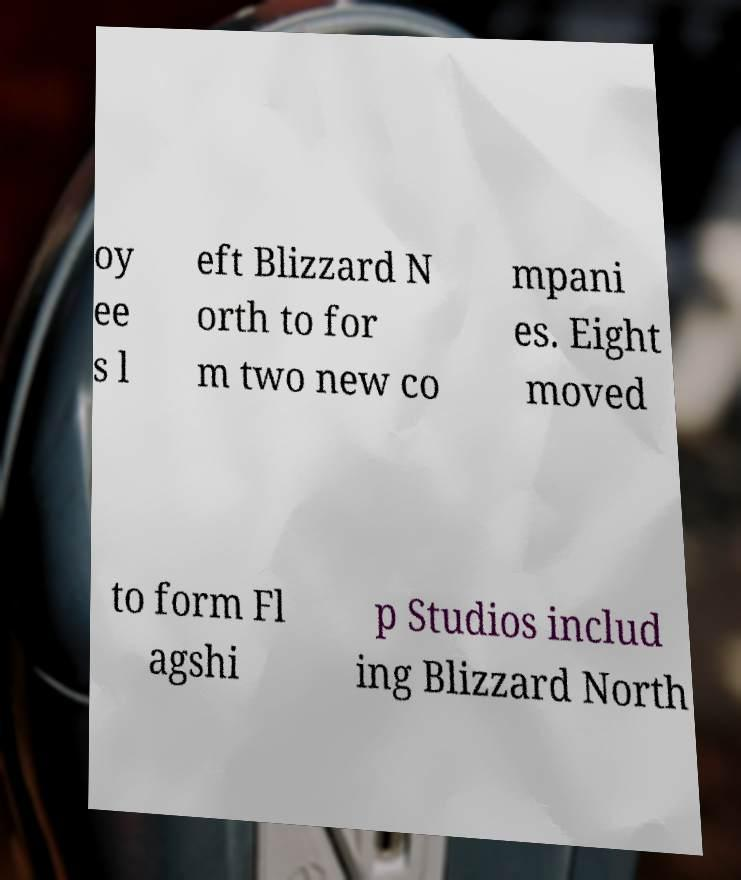Could you extract and type out the text from this image? oy ee s l eft Blizzard N orth to for m two new co mpani es. Eight moved to form Fl agshi p Studios includ ing Blizzard North 